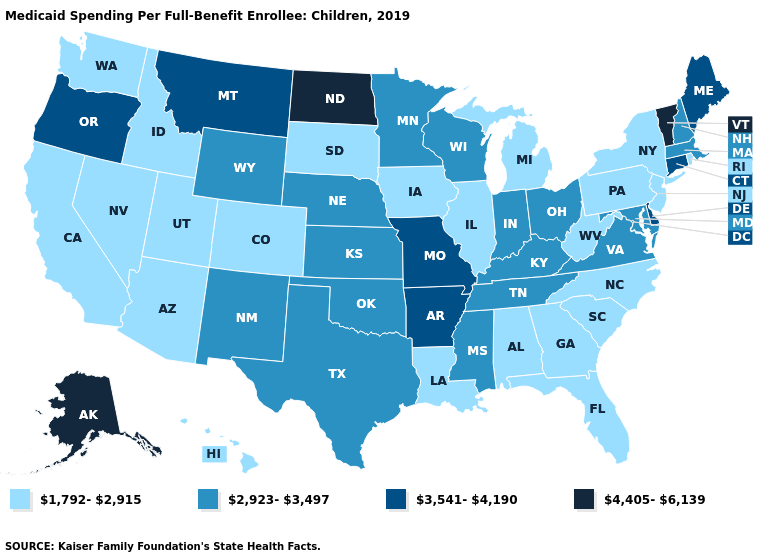Name the states that have a value in the range 4,405-6,139?
Write a very short answer. Alaska, North Dakota, Vermont. Does the first symbol in the legend represent the smallest category?
Write a very short answer. Yes. Name the states that have a value in the range 4,405-6,139?
Keep it brief. Alaska, North Dakota, Vermont. What is the value of Rhode Island?
Answer briefly. 1,792-2,915. Among the states that border Arizona , does New Mexico have the highest value?
Short answer required. Yes. Name the states that have a value in the range 2,923-3,497?
Answer briefly. Indiana, Kansas, Kentucky, Maryland, Massachusetts, Minnesota, Mississippi, Nebraska, New Hampshire, New Mexico, Ohio, Oklahoma, Tennessee, Texas, Virginia, Wisconsin, Wyoming. Does Kentucky have a lower value than Montana?
Short answer required. Yes. Does Massachusetts have a lower value than Montana?
Write a very short answer. Yes. Name the states that have a value in the range 2,923-3,497?
Write a very short answer. Indiana, Kansas, Kentucky, Maryland, Massachusetts, Minnesota, Mississippi, Nebraska, New Hampshire, New Mexico, Ohio, Oklahoma, Tennessee, Texas, Virginia, Wisconsin, Wyoming. Name the states that have a value in the range 4,405-6,139?
Give a very brief answer. Alaska, North Dakota, Vermont. What is the lowest value in the USA?
Concise answer only. 1,792-2,915. Does Iowa have the highest value in the MidWest?
Answer briefly. No. Does Indiana have the lowest value in the USA?
Be succinct. No. Is the legend a continuous bar?
Give a very brief answer. No. Name the states that have a value in the range 3,541-4,190?
Answer briefly. Arkansas, Connecticut, Delaware, Maine, Missouri, Montana, Oregon. 